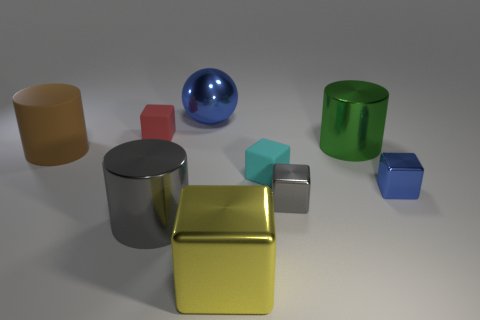What kind of mood or theme do you think this arrangement of objects expresses? The arrangement of objects and their pristine condition evoke a sense of order and calmness. The simplicity of forms and the cool, soft lighting might imply a modern and minimalist theme. The image could represent concepts such as harmony, balance, or precision, suggesting a controlled and deliberate design, often seen in product demonstrations, 3D modeling showcases, or educational contexts highlighting geometric shapes and properties. 